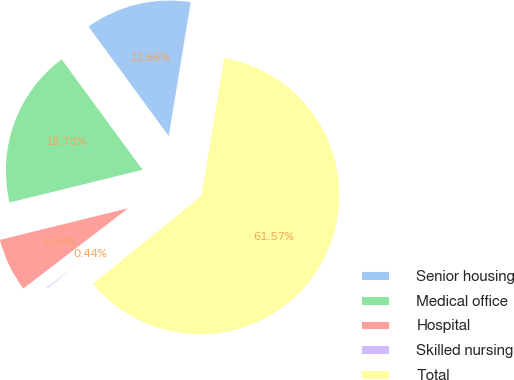<chart> <loc_0><loc_0><loc_500><loc_500><pie_chart><fcel>Senior housing<fcel>Medical office<fcel>Hospital<fcel>Skilled nursing<fcel>Total<nl><fcel>12.66%<fcel>18.78%<fcel>6.55%<fcel>0.44%<fcel>61.57%<nl></chart> 